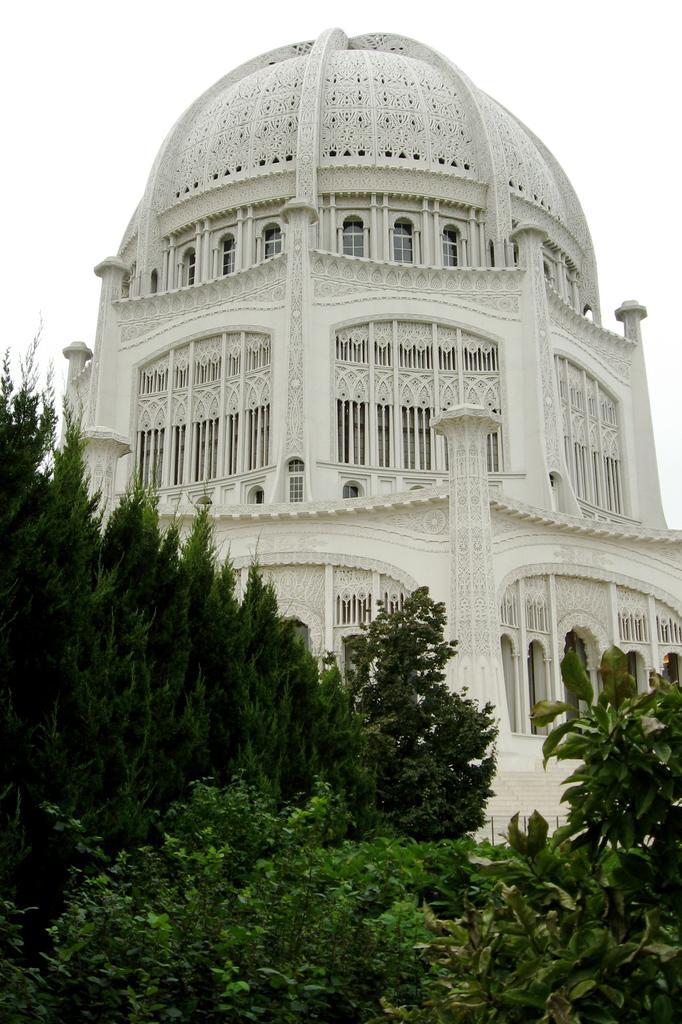Could you give a brief overview of what you see in this image? In this image there is the sky truncated towards the top of the image, there is a building truncated towards the right of the image, there are windows, there are plants truncated towards the bottom of the image, there are plants truncated towards the right of the image, there are plants truncated towards the left of the image. 